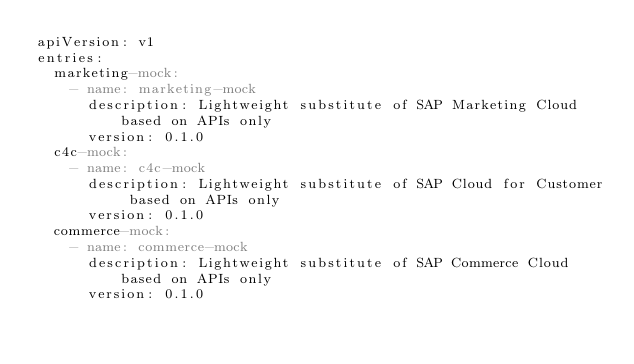Convert code to text. <code><loc_0><loc_0><loc_500><loc_500><_YAML_>apiVersion: v1
entries:
  marketing-mock:
    - name: marketing-mock
      description: Lightweight substitute of SAP Marketing Cloud based on APIs only
      version: 0.1.0
  c4c-mock:
    - name: c4c-mock
      description: Lightweight substitute of SAP Cloud for Customer based on APIs only
      version: 0.1.0
  commerce-mock:
    - name: commerce-mock
      description: Lightweight substitute of SAP Commerce Cloud based on APIs only
      version: 0.1.0</code> 